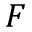Convert formula to latex. <formula><loc_0><loc_0><loc_500><loc_500>F</formula> 